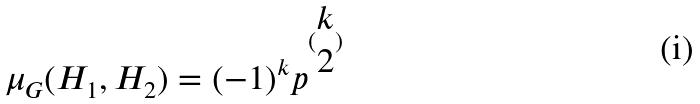<formula> <loc_0><loc_0><loc_500><loc_500>\mu _ { G } ( H _ { 1 } , H _ { 2 } ) = ( - 1 ) ^ { k } p ^ { ( \begin{matrix} k \\ 2 \end{matrix} ) }</formula> 